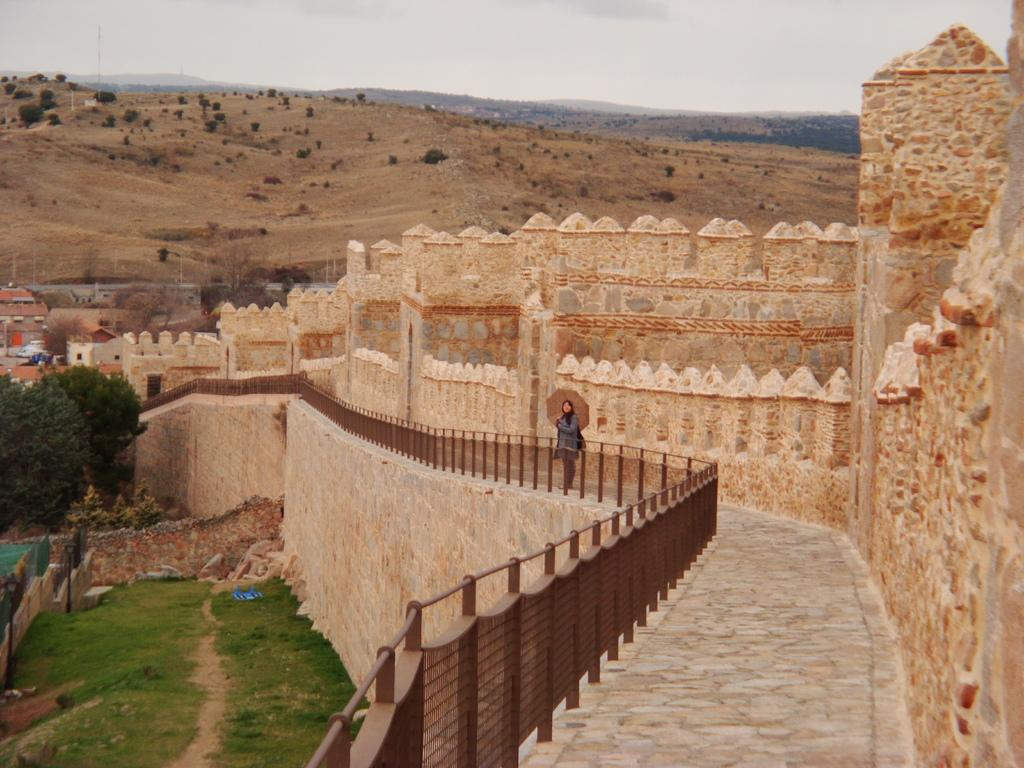What is the main subject of the image? There is a person standing in the image. What can be seen near the person in the image? There is railing visible in the image. What type of structure is present in the image? There is a fort in the image. What type of vegetation is visible in the image? Grass and trees are present in the image. What type of terrain is visible in the image? Hills are visible in the image. What is visible in the background of the image? The sky is visible in the background of the image. What type of bread is being served at the attraction in the image? There is no attraction or bread present in the image; it features a person standing near a fort with a stone wall, grass, trees, hills, and the sky visible in the background. What is the queen doing in the image? There is no queen present in the image; it features a person standing near a fort with a stone wall, grass, trees, hills, and the sky visible in the background. 